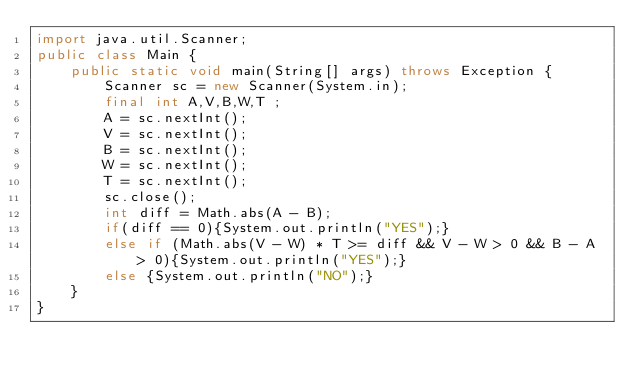Convert code to text. <code><loc_0><loc_0><loc_500><loc_500><_Java_>import java.util.Scanner;
public class Main {
    public static void main(String[] args) throws Exception {
        Scanner sc = new Scanner(System.in);
        final int A,V,B,W,T ;
        A = sc.nextInt();
        V = sc.nextInt();
        B = sc.nextInt();
        W = sc.nextInt();
        T = sc.nextInt();
        sc.close();
        int diff = Math.abs(A - B);
        if(diff == 0){System.out.println("YES");}
        else if (Math.abs(V - W) * T >= diff && V - W > 0 && B - A > 0){System.out.println("YES");}
        else {System.out.println("NO");}
    }
}</code> 